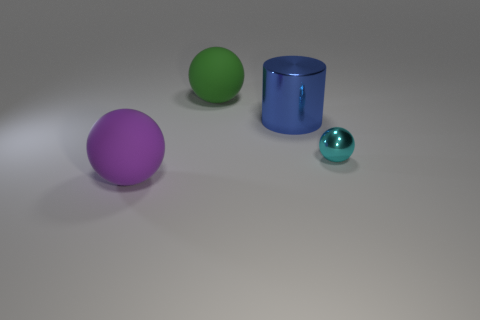The big ball that is made of the same material as the large green thing is what color? purple 